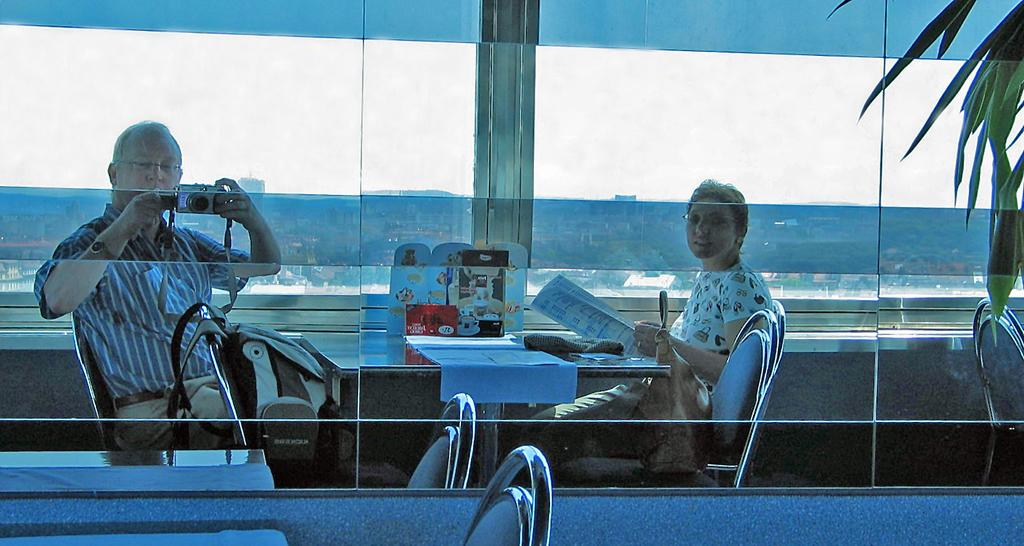How many people are present in the image? There are two people in the image. What object can be seen in the image that is typically used for drinking? There is a glass in the image. What type of furniture is present in the image? There are chairs and tables in the image. What device is used to capture the scene in the image? There is a camera in the image. What can be seen through the glass in the image? Trees and houses are visible behind the glass. What idea does the appliance in the image represent? There is no appliance present in the image, so it cannot represent any idea. 